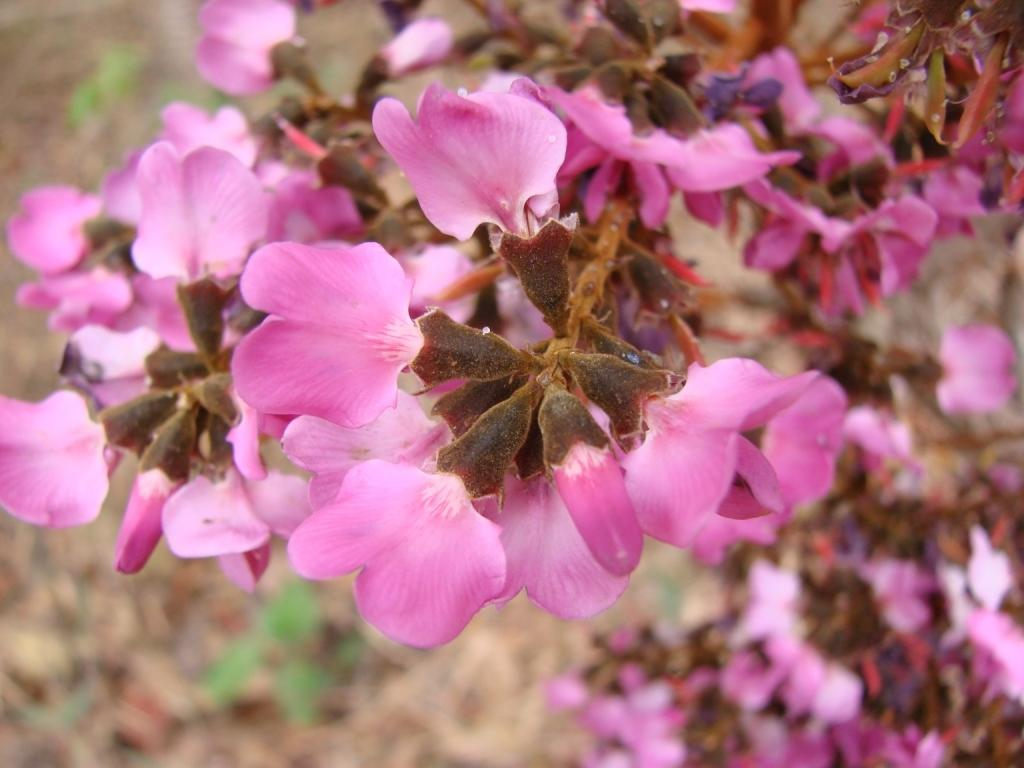What type of living organisms can be seen in the image? There are flowers in the image. Can you describe the background of the image? The background of the image is blurred. What type of stew is being prepared in the image? There is no stew present in the image; it features flowers and a blurred background. What season is depicted in the image? The image does not depict a specific season, as there are no seasonal cues present. 